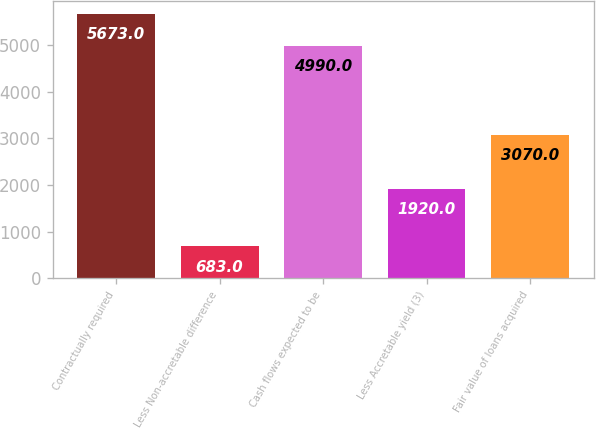<chart> <loc_0><loc_0><loc_500><loc_500><bar_chart><fcel>Contractually required<fcel>Less Non-accretable difference<fcel>Cash flows expected to be<fcel>Less Accretable yield (3)<fcel>Fair value of loans acquired<nl><fcel>5673<fcel>683<fcel>4990<fcel>1920<fcel>3070<nl></chart> 